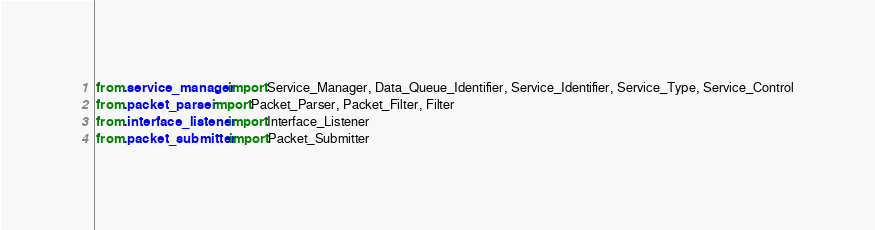Convert code to text. <code><loc_0><loc_0><loc_500><loc_500><_Python_>from .service_manager import Service_Manager, Data_Queue_Identifier, Service_Identifier, Service_Type, Service_Control
from .packet_parser import Packet_Parser, Packet_Filter, Filter
from .interface_listener import Interface_Listener
from .packet_submitter import Packet_Submitter
</code> 